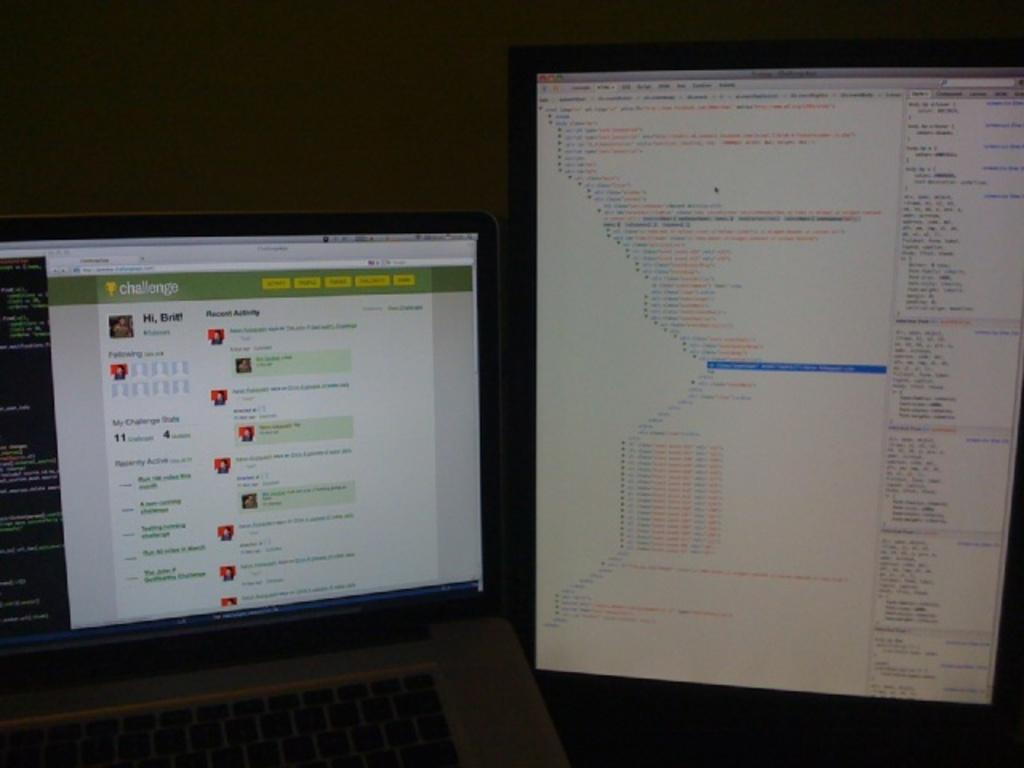<image>
Give a short and clear explanation of the subsequent image. A computer monitor has the word "challenge" in the upper left corner. 